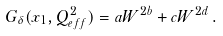<formula> <loc_0><loc_0><loc_500><loc_500>G _ { \delta } ( x _ { 1 } , Q ^ { 2 } _ { e f f } ) = a W ^ { 2 b } + c W ^ { 2 d } \, .</formula> 